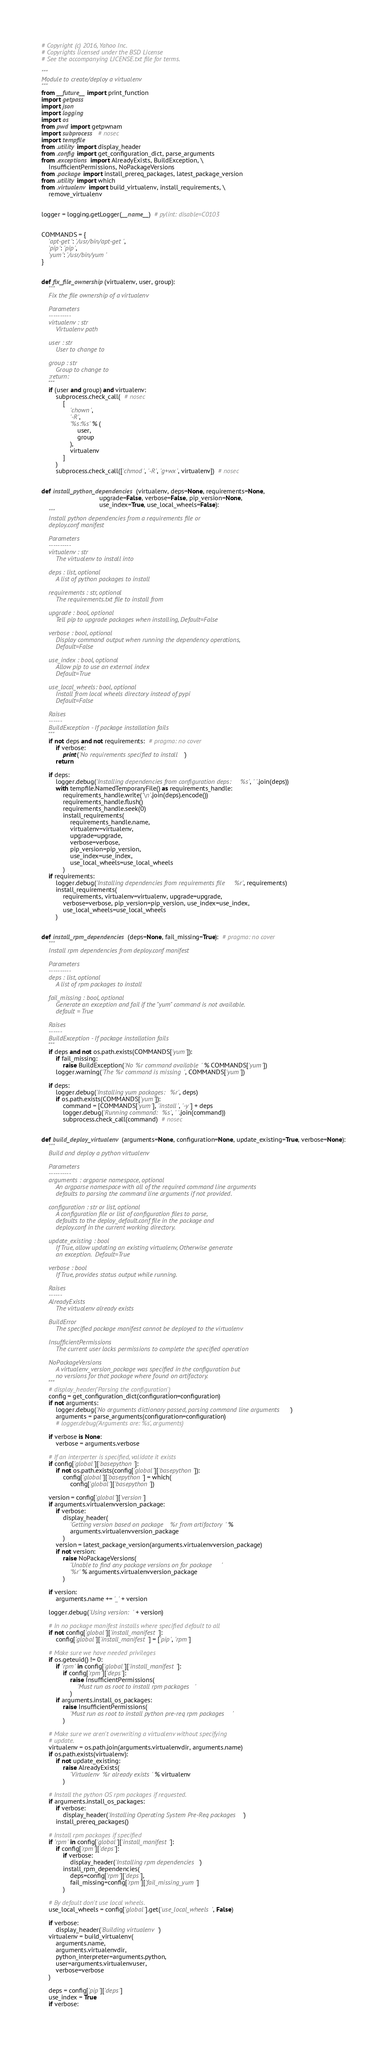<code> <loc_0><loc_0><loc_500><loc_500><_Python_># Copyright (c) 2016, Yahoo Inc.
# Copyrights licensed under the BSD License
# See the accompanying LICENSE.txt file for terms.

"""
Module to create/deploy a virtualenv
"""
from __future__ import print_function
import getpass
import json
import logging
import os
from pwd import getpwnam
import subprocess  # nosec
import tempfile
from .utility import display_header
from .config import get_configuration_dict, parse_arguments
from .exceptions import AlreadyExists, BuildException, \
    InsufficientPermissions, NoPackageVersions
from .package import install_prereq_packages, latest_package_version
from .utility import which
from .virtualenv import build_virtualenv, install_requirements, \
    remove_virtualenv


logger = logging.getLogger(__name__)  # pylint: disable=C0103


COMMANDS = {
    'apt-get': '/usr/bin/apt-get',
    'pip': 'pip',
    'yum': '/usr/bin/yum'
}


def fix_file_ownership(virtualenv, user, group):
    """
    Fix the file ownership of a virtualenv

    Parameters
    ----------
    virtualenv : str
        Virtualenv path

    user : str
        User to change to

    group : str
        Group to change to
    :return:
    """
    if (user and group) and virtualenv:
        subprocess.check_call(  # nosec
            [
                'chown',
                '-R',
                '%s:%s' % (
                    user,
                    group
                ),
                virtualenv
            ]
        )
        subprocess.check_call(['chmod', '-R', 'g+wx', virtualenv])  # nosec


def install_python_dependencies(virtualenv, deps=None, requirements=None,
                                upgrade=False, verbose=False, pip_version=None,
                                use_index=True, use_local_wheels=False):
    """
    Install python dependencies from a requirements file or
    deploy.conf manifest

    Parameters
    ----------
    virtualenv : str
        The virtualenv to install into

    deps : list, optional
        A list of python packages to install

    requirements : str, optional
        The requirements.txt file to install from

    upgrade : bool, optional
        Tell pip to upgrade packages when installing, Default=False

    verbose : bool, optional
        Display command output when running the dependency operations,
        Default=False

    use_index : bool, optional
        Allow pip to use an external index
        Default=True

    use_local_wheels: bool, optional
        Install from local wheels directory instead of pypi
        Default=False

    Raises
    ------
    BuildException - If package installation fails
    """
    if not deps and not requirements:  # pragma: no cover
        if verbose:
            print('No requirements specified to install')
        return

    if deps:
        logger.debug('Installing dependencies from configuration deps: %s', ' '.join(deps))
        with tempfile.NamedTemporaryFile() as requirements_handle:
            requirements_handle.write('\n'.join(deps).encode())
            requirements_handle.flush()
            requirements_handle.seek(0)
            install_requirements(
                requirements_handle.name,
                virtualenv=virtualenv,
                upgrade=upgrade,
                verbose=verbose,
                pip_version=pip_version,
                use_index=use_index,
                use_local_wheels=use_local_wheels
            )
    if requirements:
        logger.debug('Installing dependencies from requirements file %r', requirements)
        install_requirements(
            requirements, virtualenv=virtualenv, upgrade=upgrade,
            verbose=verbose, pip_version=pip_version, use_index=use_index,
            use_local_wheels=use_local_wheels
        )


def install_rpm_dependencies(deps=None, fail_missing=True):  # pragma: no cover
    """
    Install rpm dependencies from deploy.conf manifest

    Parameters
    ----------
    deps : list, optional
        A list of rpm packages to install

    fail_missing : bool, optional
        Generate an exception and fail if the "yum" command is not available.
        default = True

    Raises
    ------
    BuildException - If package installation fails
    """
    if deps and not os.path.exists(COMMANDS['yum']):
        if fail_missing:
            raise BuildException('No %r command available' % COMMANDS['yum'])
        logger.warning('The %r command is missing', COMMANDS['yum'])

    if deps:
        logger.debug('Installing yum packages: %r', deps)
        if os.path.exists(COMMANDS['yum']):
            command = [COMMANDS['yum'], 'install', '-y'] + deps
            logger.debug('Running command: %s', ' '.join(command))
            subprocess.check_call(command)  # nosec


def build_deploy_virtualenv(arguments=None, configuration=None, update_existing=True, verbose=None):
    """
    Build and deploy a python virtualenv

    Parameters
    ----------
    arguments : argparse namespace, optional
        An argparse namespace with all of the required command line arguments
        defaults to parsing the command line arguments if not provided.

    configuration : str or list, optional
        A configuration file or list of configuration files to parse,
        defaults to the deploy_default.conf file in the package and
        deploy.conf in the current working directory.

    update_existing : bool
        If True, allow updating an existing virtualenv, Otherwise generate
        an exception.  Default=True

    verbose : bool
        If True, provides status output while running.

    Raises
    ------
    AlreadyExists
        The virtualenv already exists

    BuildError
        The specified package manifest cannot be deployed to the virtualenv

    InsufficientPermissions
        The current user lacks permissions to complete the specified operation

    NoPackageVersions
        A virtualenv_version_package was specified in the configuration but
        no versions for that package where found on artifactory.
    """
    # display_header('Parsing the configuration')
    config = get_configuration_dict(configuration=configuration)
    if not arguments:
        logger.debug('No arguments dictionary passed, parsing command line arguments')
        arguments = parse_arguments(configuration=configuration)
        # logger.debug('Arguments are: %s', arguments)

    if verbose is None:
        verbose = arguments.verbose

    # If an interperter is specified, validate it exists
    if config['global']['basepython']:
        if not os.path.exists(config['global']['basepython']):
            config['global']['basepython'] = which(
                config['global']['basepython'])

    version = config['global']['version']
    if arguments.virtualenvversion_package:
        if verbose:
            display_header(
                'Getting version based on package %r from artifactory' %
                arguments.virtualenvversion_package
            )
        version = latest_package_version(arguments.virtualenvversion_package)
        if not version:
            raise NoPackageVersions(
                'Unable to find any package versions on for package '
                '%r' % arguments.virtualenvversion_package
            )

    if version:
        arguments.name += '_' + version

    logger.debug('Using version: ' + version)

    # In no package manifest installs where specified default to all
    if not config['global']['install_manifest']:
        config['global']['install_manifest'] = ['pip', 'rpm']

    # Make sure we have needed privileges
    if os.geteuid() != 0:
        if 'rpm' in config['global']['install_manifest']:
            if config['rpm']['deps']:
                raise InsufficientPermissions(
                    'Must run as root to install rpm packages'
                )
        if arguments.install_os_packages:
            raise InsufficientPermissions(
                'Must run as root to install python pre-req rpm packages'
            )

    # Make sure we aren't overwriting a virtualenv without specifying
    # update.
    virtualenv = os.path.join(arguments.virtualenvdir, arguments.name)
    if os.path.exists(virtualenv):
        if not update_existing:
            raise AlreadyExists(
                'Virtualenv %r already exists' % virtualenv
            )

    # Install the python OS rpm packages if requested.
    if arguments.install_os_packages:
        if verbose:
            display_header('Installing Operating System Pre-Req packages')
        install_prereq_packages()

    # Install rpm packages if specified
    if 'rpm' in config['global']['install_manifest']:
        if config['rpm']['deps']:
            if verbose:
                display_header('Installing rpm dependencies')
            install_rpm_dependencies(
                deps=config['rpm']['deps'],
                fail_missing=config['rpm']['fail_missing_yum']
            )

    # By default don't use local wheels.
    use_local_wheels = config['global'].get('use_local_wheels', False)

    if verbose:
        display_header('Building virtualenv')
    virtualenv = build_virtualenv(
        arguments.name,
        arguments.virtualenvdir,
        python_interpreter=arguments.python,
        user=arguments.virtualenvuser,
        verbose=verbose
    )

    deps = config['pip']['deps']
    use_index = True
    if verbose:</code> 